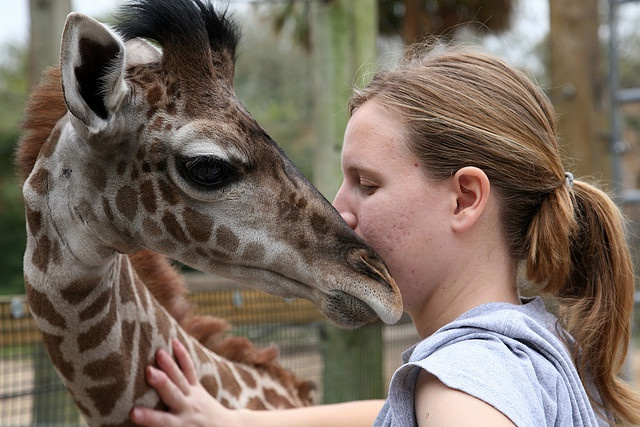Describe the objects in this image and their specific colors. I can see giraffe in white, gray, black, and maroon tones and people in white, lavender, gray, darkgray, and tan tones in this image. 